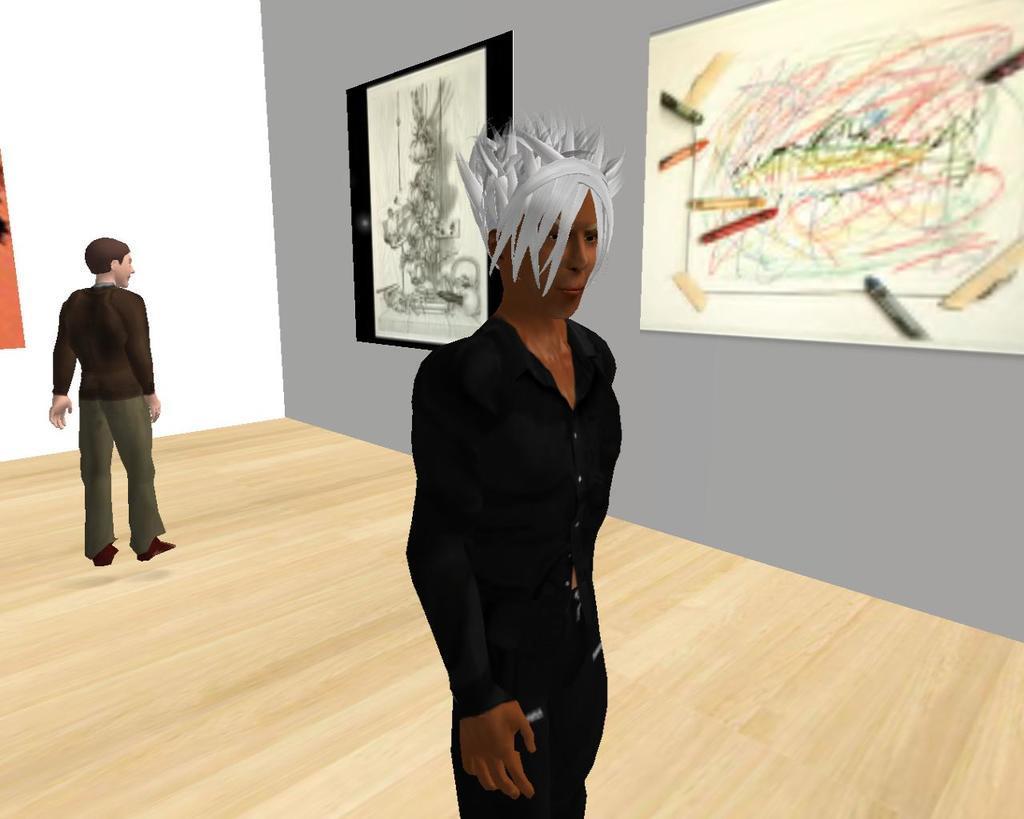Can you describe this image briefly? the picture is a animated image. In the center of the picture there is a person standing. On the right there is a painting to the wall. In the center of the background there is another painting. On the left there is a person standing. 